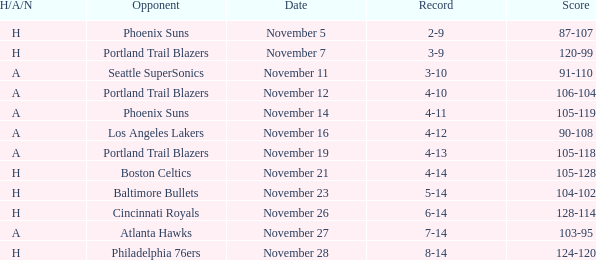On what Date was the Score 105-118 and the H/A/N A? November 19. 